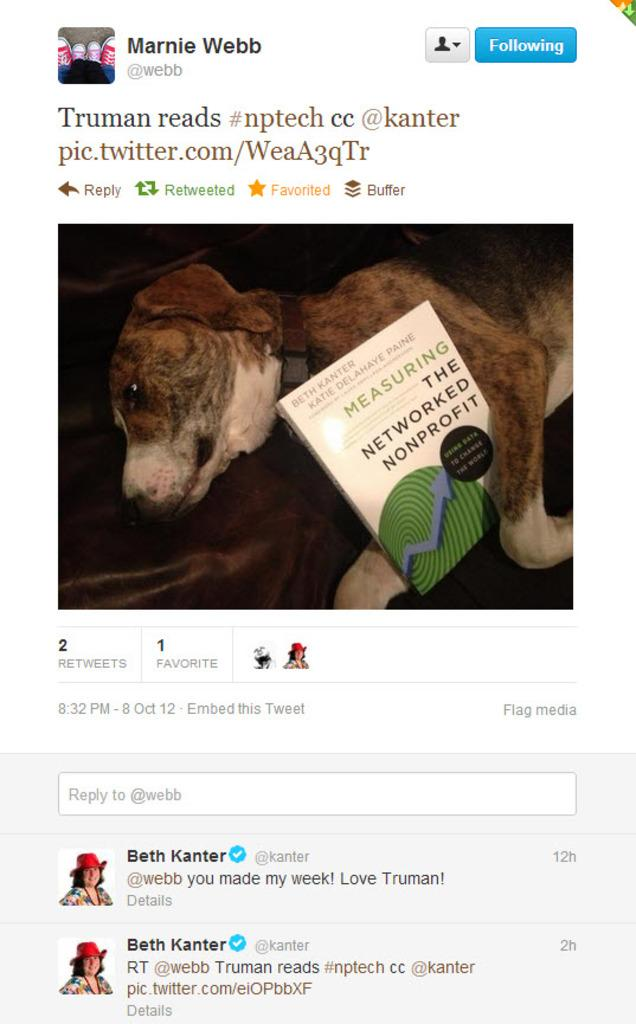What type of image is displayed in the screenshot? The image contains a screenshot, but the content of the screenshot is not specified in the facts. What other objects are visible in the image? There is a book and a dog in the image. Can you describe the appearance of the dog? The dog is brown and cream in color. What is unusual about the dog in the image? There is writing on the dog. What effect does the calculator have on the dog in the image? There is no calculator present in the image, so it cannot have any effect on the dog. 